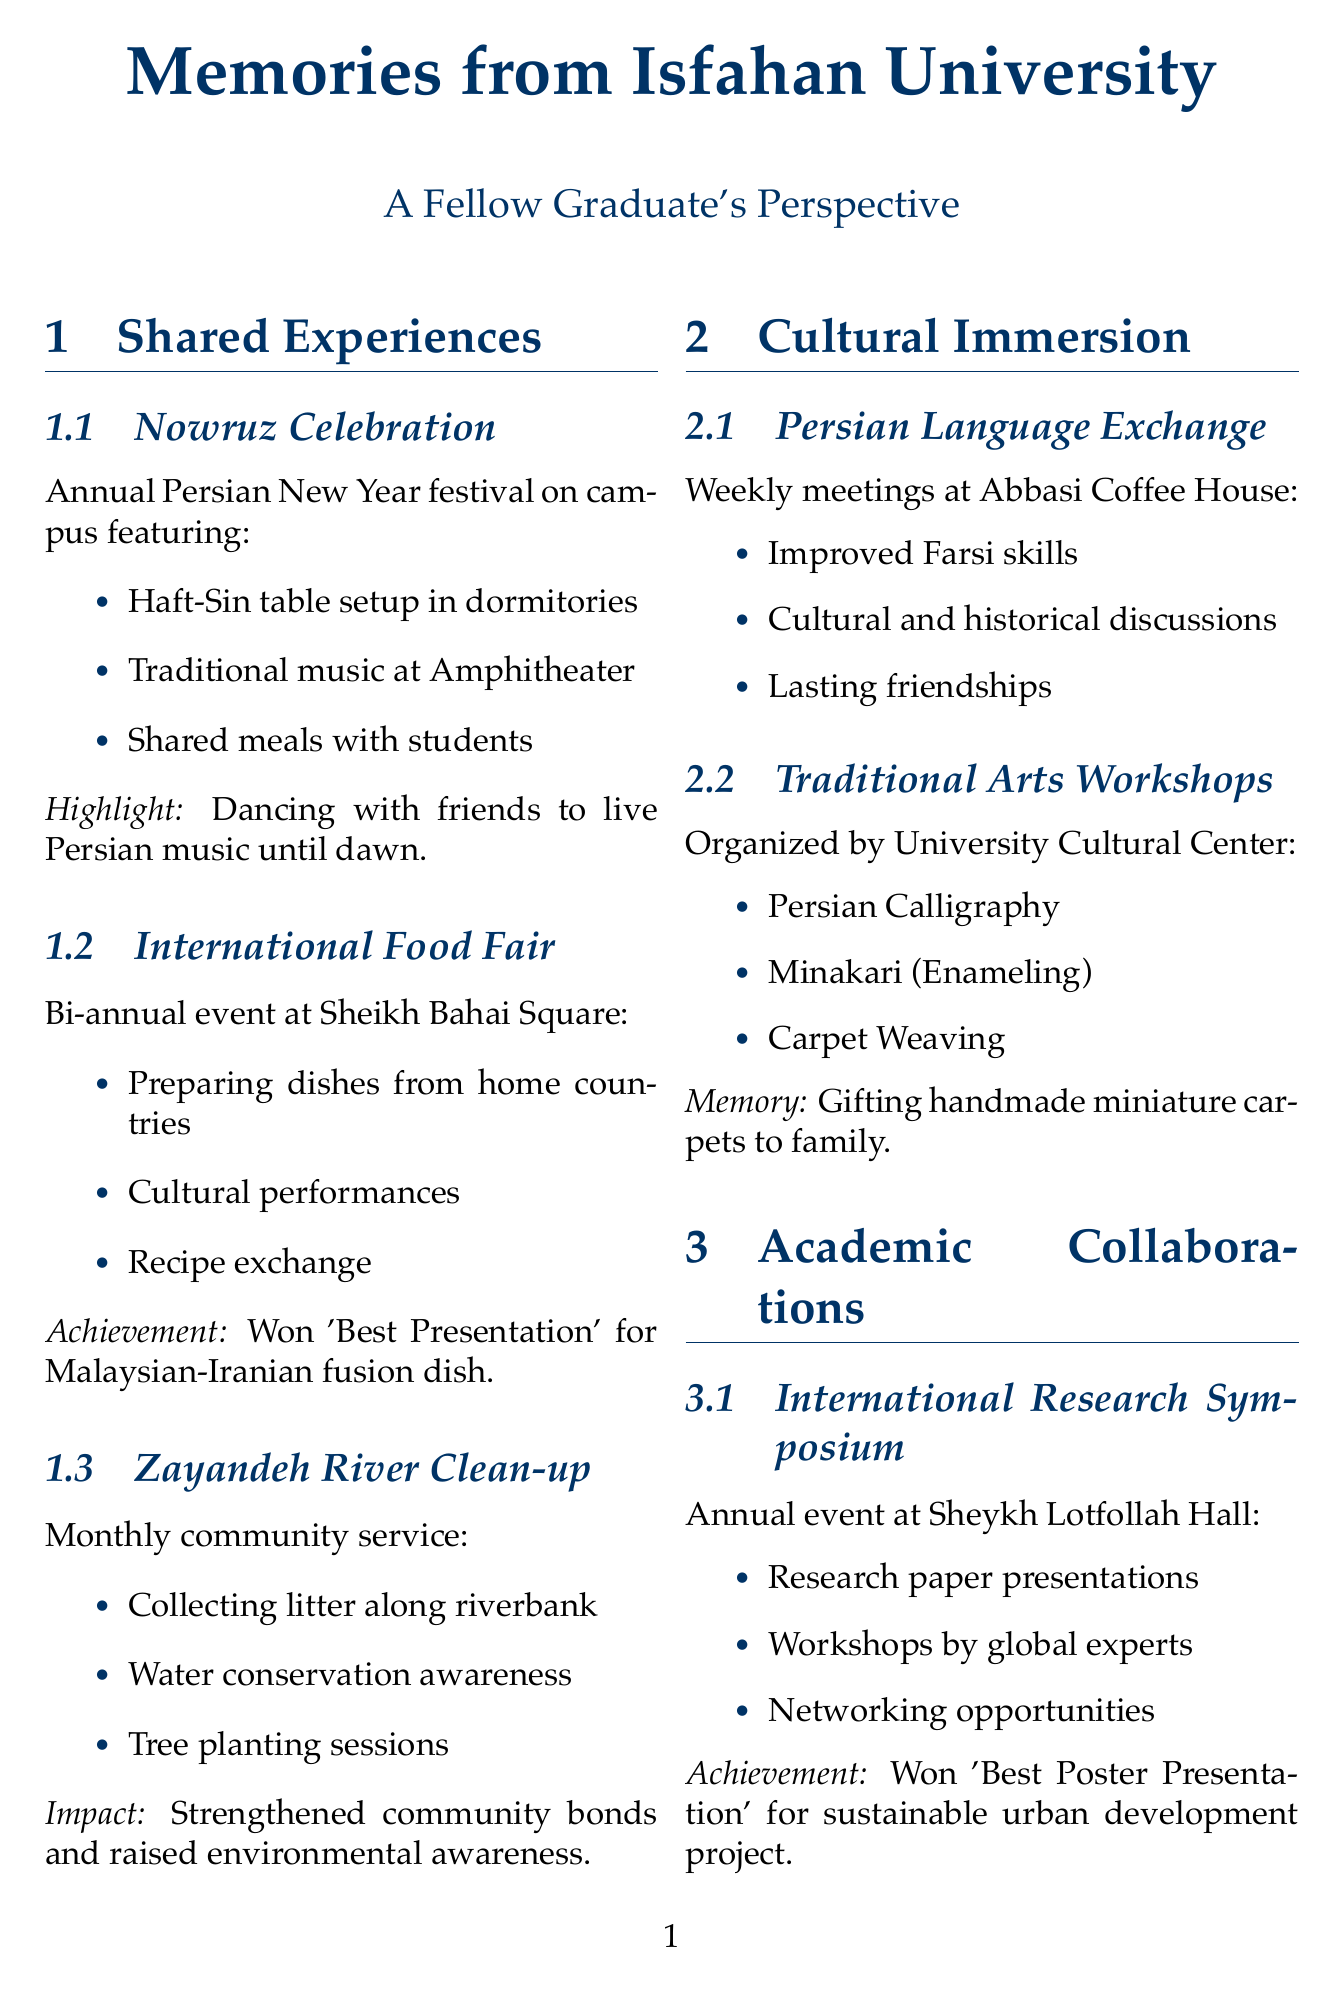What is the name of the annual festival celebrated on campus? The document mentions the Nowruz Celebration, which is the annual Persian New Year festival held on campus.
Answer: Nowruz Celebration Where does the International Food Fair take place? According to the document, the location of the International Food Fair is Sheikh Bahai Square.
Answer: Sheikh Bahai Square What activity is associated with the Zayandeh River Clean-up Initiative? The document states that one activity is collecting litter along the riverbank as part of the Zayandeh River Clean-up Initiative.
Answer: Collecting litter along the riverbank How often do the Persian Language Exchange meetings occur? The document specifies that the Persian Language Exchange Program meets weekly.
Answer: Weekly What was a personal achievement at the International Research Symposium? The document highlights winning 'Best Poster Presentation' for the group project on sustainable urban development as a personal achievement.
Answer: Best Poster Presentation What is the primary role of the International Students Association? The document describes the role of an active member and event coordinator within the International Students Association.
Answer: Event coordinator How did organizing inclusive celebrations help with homesickness? The document indicates that organizing inclusive celebrations blending various cultural traditions created a sense of family among diverse student groups.
Answer: Created a sense of family What is the main goal of the cross-cultural management case competition? The document states that it enhances cross-cultural communication skills as one of its main goals.
Answer: Enhanced cross-cultural communication skills Which cultural activity involved making and gifting carpets? The document mentions that in the Traditional Arts Workshop Series, gifting handmade miniature carpets to family back home was a memorable experience.
Answer: Gifting handmade miniature carpets 